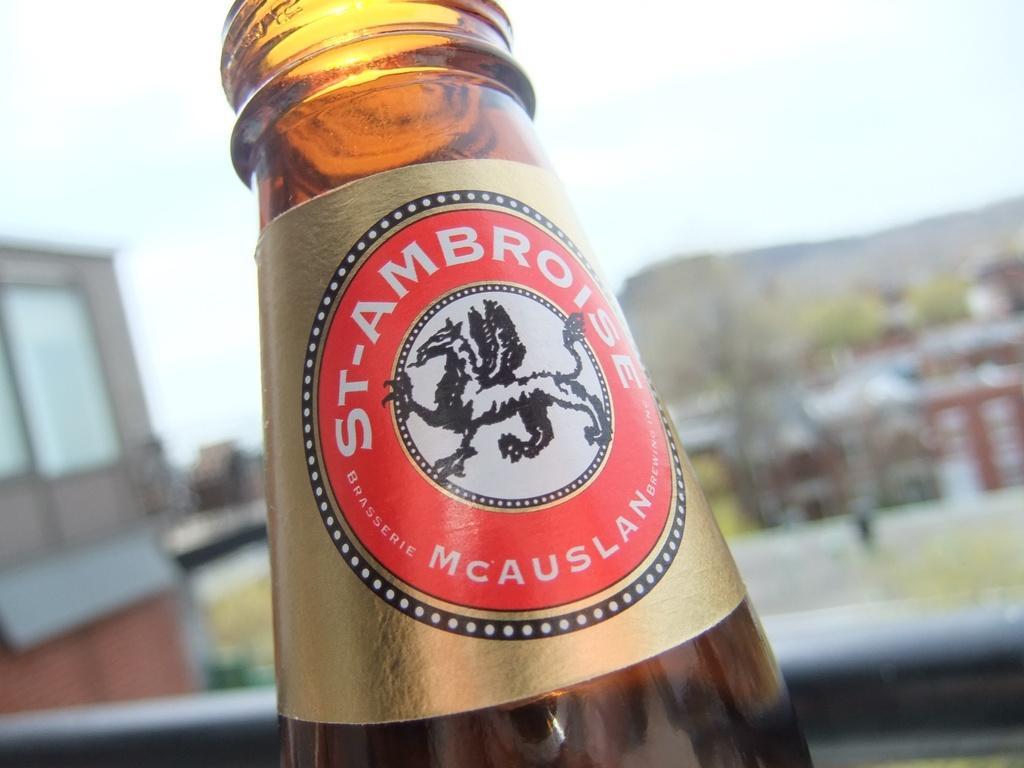How would you summarize this image in a sentence or two? In this image I see a bottle on which there is an animal photo. 